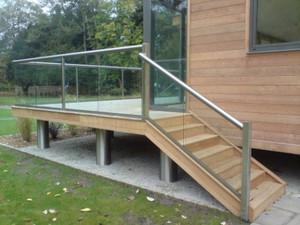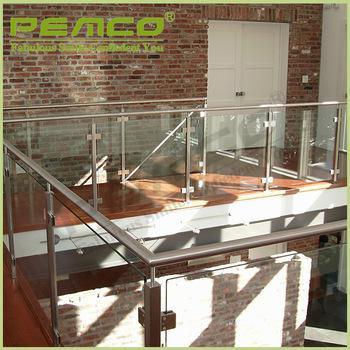The first image is the image on the left, the second image is the image on the right. Examine the images to the left and right. Is the description "One image shows a glass-paneled balcony with a corner on the left, a flat metal rail across the top, and no hinges connecting the balcony panels, and the other image shows a railing with horizontal bars." accurate? Answer yes or no. No. The first image is the image on the left, the second image is the image on the right. Examine the images to the left and right. Is the description "The building in the image on the right is made of bricks." accurate? Answer yes or no. Yes. 